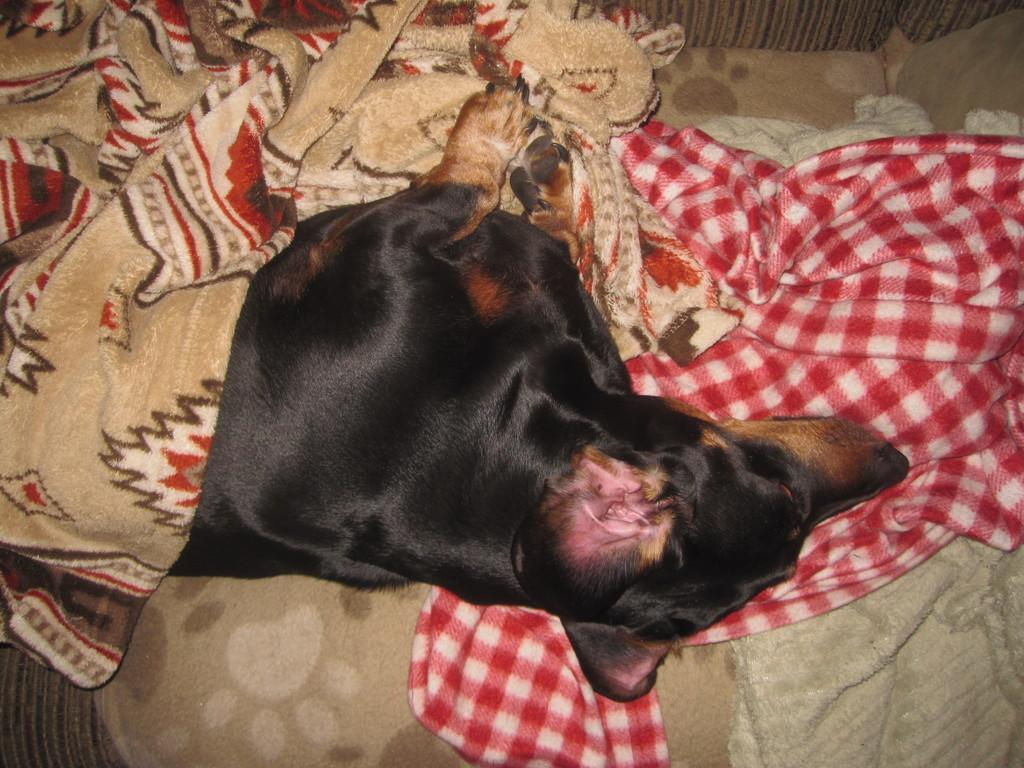What type of animal is in the image? There is a dog in the image. Where is the dog located? The dog is lying on a sofa. What else can be seen in the image besides the dog? There is a blanket and a bedsheet in the image. How many frogs are hopping in the garden in the image? There are no frogs or gardens present in the image; it features a dog lying on a sofa with a blanket and bedsheet. 